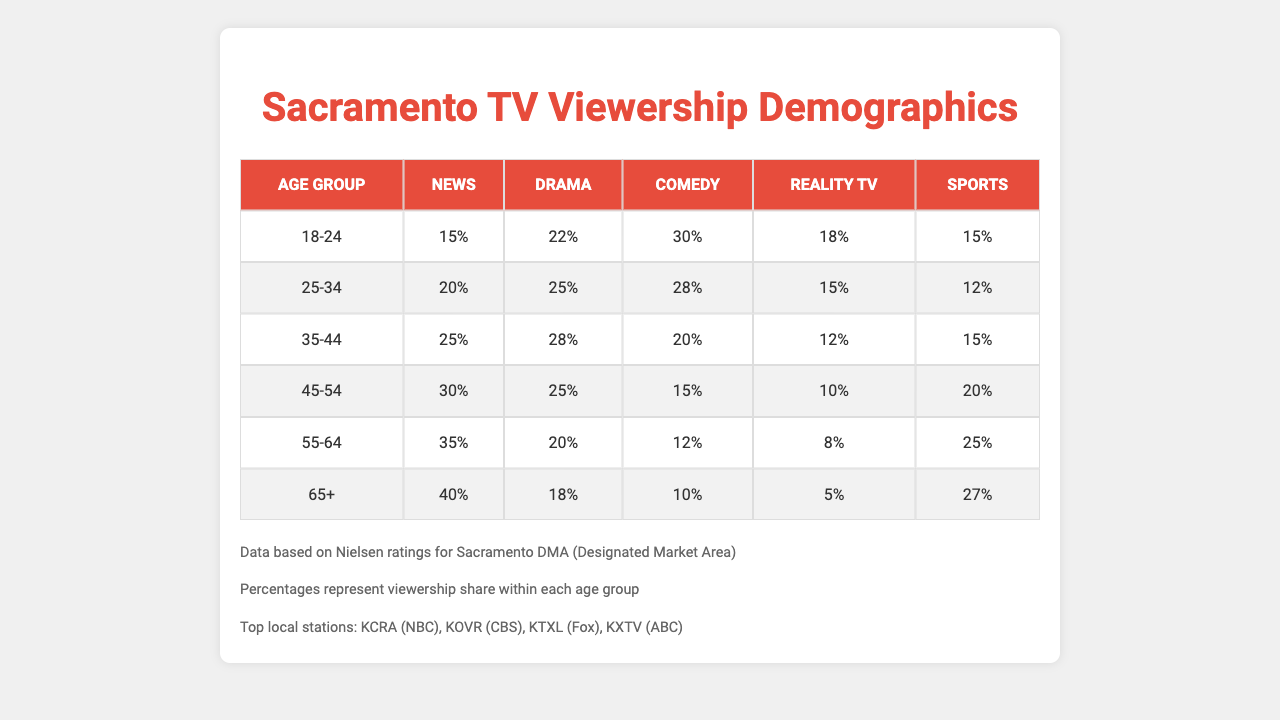What percentage of viewers aged 18-24 prefer Comedy? In the table, looking under the "Comedy" column for the age group "18-24", the value is 30%.
Answer: 30% Which age group has the highest preference for Sports? By scanning through the "Sports" column across all age groups, the "55-64" group shows the highest preference at 25%.
Answer: 55-64 What is the average percentage of Drama viewers across all age groups? To find the average for "Drama", add the values: 22% + 25% + 28% + 25% + 20% + 18% = 138%. Then divide by 6 (the number of age groups): 138% / 6 = 23%.
Answer: 23% Is there any age group where Reality TV viewership exceeds 20%? Checking the "Reality TV" column, the only age group with more than 20% is "18-24" at 18% and "25-34" at 15%. Therefore, none exceed 20%.
Answer: No What is the difference in percentage of News viewership between the 45-54 age group and the 65+ age group? The News viewership for the 45-54 group is 30%, while for the 65+ group it is 40%. The difference is 40% - 30% = 10%.
Answer: 10% Which genre is least preferred by the 35-44 age group? For the 35-44 age group, the genre with the lowest percentage is Comedy at 20%.
Answer: Comedy If we combine the viewership percentages for Comedy and Reality TV in the 25-34 age group, what total percentage do we get? The preference for Comedy in the 25-34 age group is 28% and for Reality TV, it is 15%. Adding these values gives 28% + 15% = 43%.
Answer: 43% Does viewership for Sports increase or decrease with age? By comparing the percentages in the "Sports" column from the youngest group (15%) to the oldest (27%), we see an increase in viewership as age increases.
Answer: Increase What is the median percentage of viewers across all genres for the 55-64 age group? The percentages for the 55-64 age group are: 35% (News), 20% (Drama), 12% (Comedy), 8% (Reality TV), and 25% (Sports). Arranging them from lowest to highest gives: 8%, 12%, 20%, 25%, 35%. The middle value (median) is 20%.
Answer: 20% What is the total percentage of viewers aged 45-54 who prefer Drama and Comedy combined? The percentage for Drama in the 45-54 age group is 25% and for Comedy is 15%. Adding these figures yields 25% + 15% = 40%.
Answer: 40% 